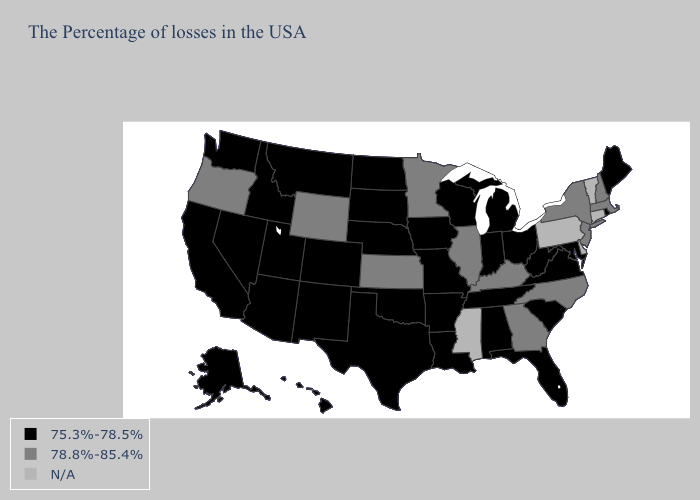Which states hav the highest value in the Northeast?
Quick response, please. Massachusetts, New Hampshire, New York, New Jersey. Does New Jersey have the highest value in the Northeast?
Concise answer only. Yes. What is the value of West Virginia?
Quick response, please. 75.3%-78.5%. Which states hav the highest value in the MidWest?
Keep it brief. Illinois, Minnesota, Kansas. Which states have the lowest value in the USA?
Concise answer only. Maine, Rhode Island, Maryland, Virginia, South Carolina, West Virginia, Ohio, Florida, Michigan, Indiana, Alabama, Tennessee, Wisconsin, Louisiana, Missouri, Arkansas, Iowa, Nebraska, Oklahoma, Texas, South Dakota, North Dakota, Colorado, New Mexico, Utah, Montana, Arizona, Idaho, Nevada, California, Washington, Alaska, Hawaii. What is the value of Tennessee?
Be succinct. 75.3%-78.5%. What is the value of Missouri?
Be succinct. 75.3%-78.5%. Does the map have missing data?
Write a very short answer. Yes. Name the states that have a value in the range 78.8%-85.4%?
Answer briefly. Massachusetts, New Hampshire, New York, New Jersey, North Carolina, Georgia, Kentucky, Illinois, Minnesota, Kansas, Wyoming, Oregon. What is the value of New Mexico?
Keep it brief. 75.3%-78.5%. Does Florida have the highest value in the USA?
Keep it brief. No. What is the lowest value in the MidWest?
Concise answer only. 75.3%-78.5%. Is the legend a continuous bar?
Short answer required. No. 